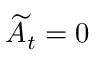<formula> <loc_0><loc_0><loc_500><loc_500>\widetilde { A } _ { t } = 0</formula> 